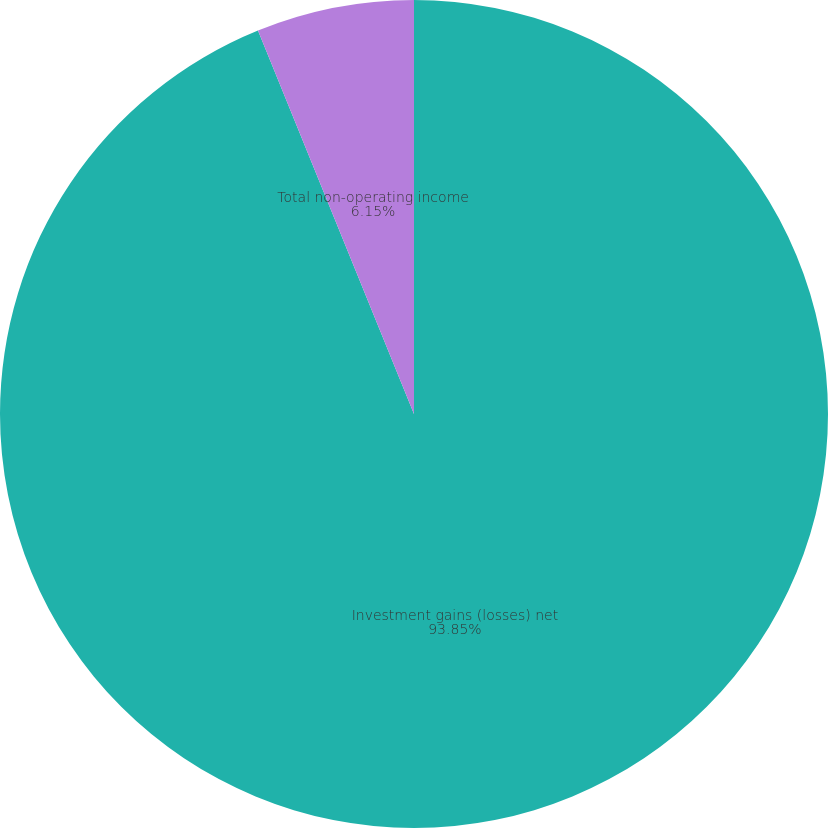Convert chart. <chart><loc_0><loc_0><loc_500><loc_500><pie_chart><fcel>Investment gains (losses) net<fcel>Total non-operating income<nl><fcel>93.85%<fcel>6.15%<nl></chart> 